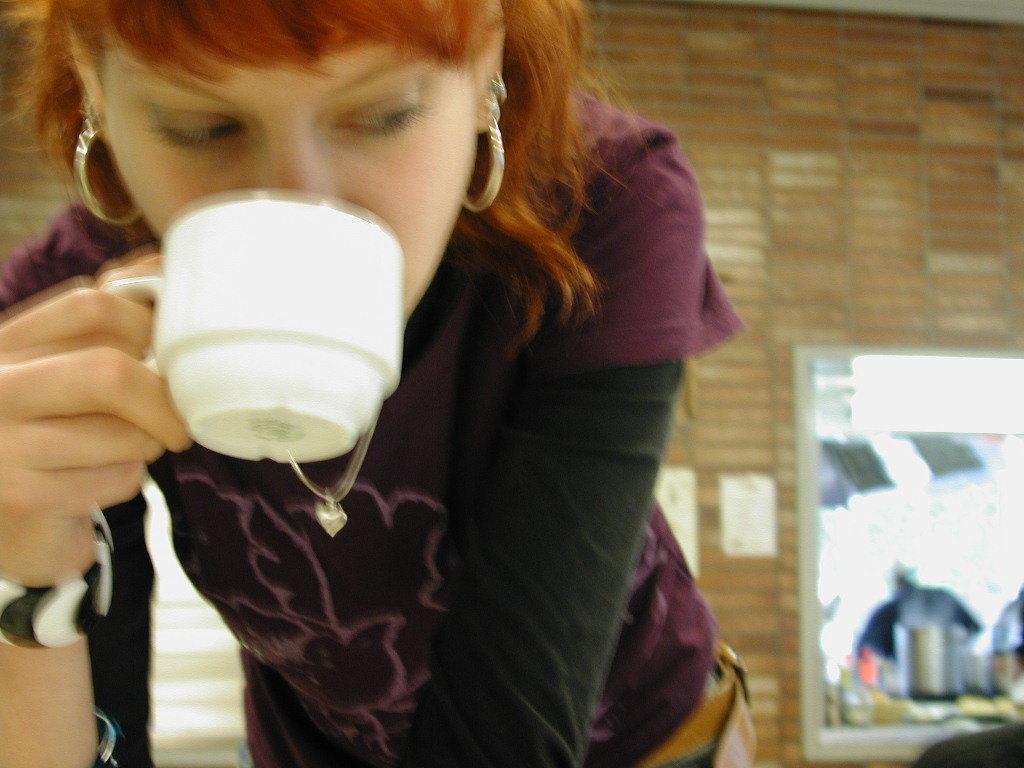Could you give a brief overview of what you see in this image? In this image, at the left side we can see a woman holding a white color cup and she is drinking something, in the background there is a brick wall. 